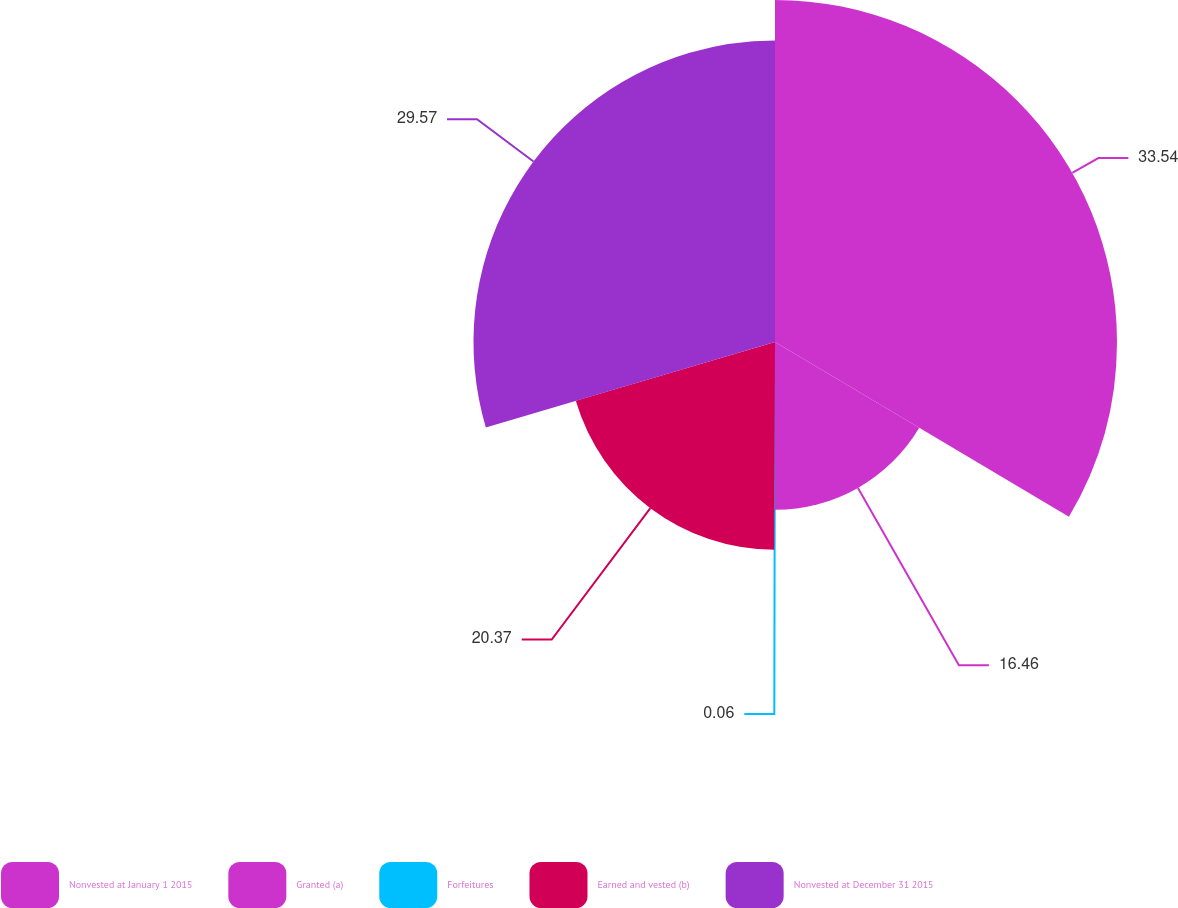Convert chart. <chart><loc_0><loc_0><loc_500><loc_500><pie_chart><fcel>Nonvested at January 1 2015<fcel>Granted (a)<fcel>Forfeitures<fcel>Earned and vested (b)<fcel>Nonvested at December 31 2015<nl><fcel>33.54%<fcel>16.46%<fcel>0.06%<fcel>20.37%<fcel>29.57%<nl></chart> 